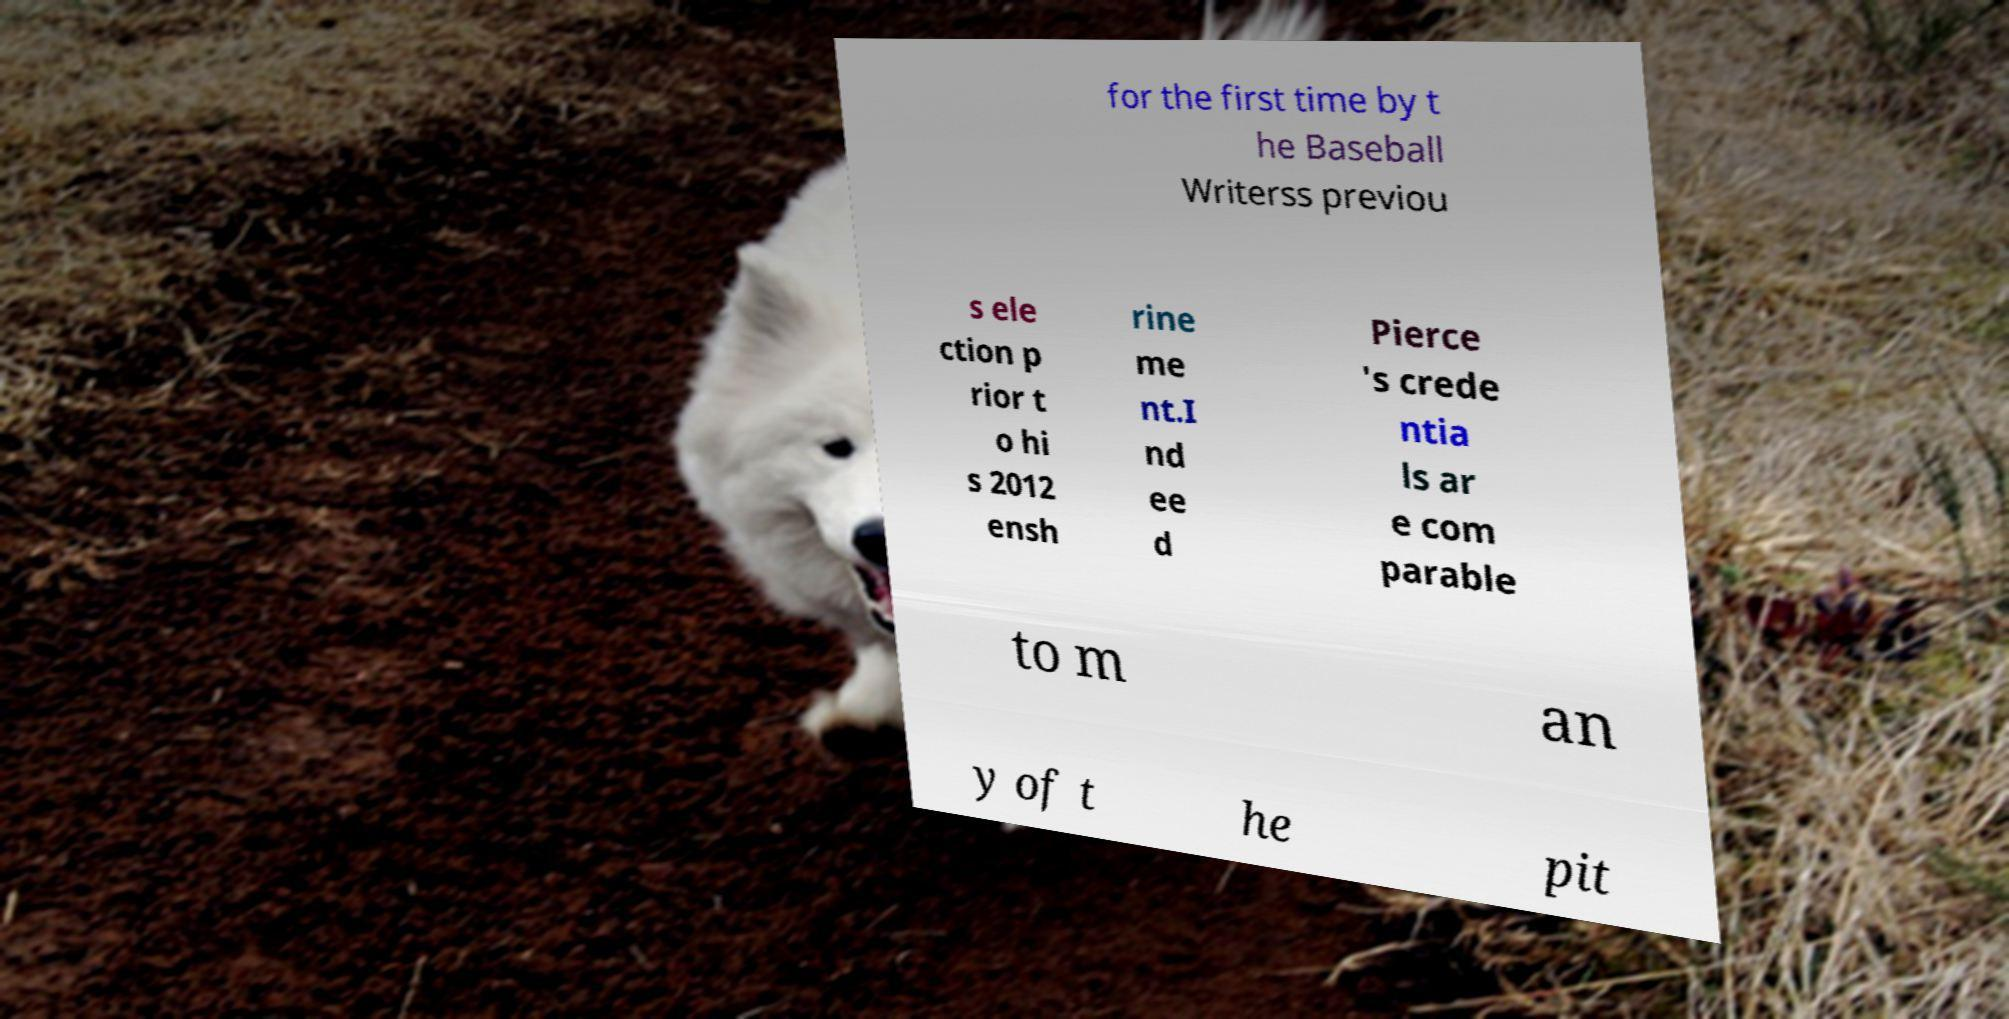There's text embedded in this image that I need extracted. Can you transcribe it verbatim? for the first time by t he Baseball Writerss previou s ele ction p rior t o hi s 2012 ensh rine me nt.I nd ee d Pierce 's crede ntia ls ar e com parable to m an y of t he pit 